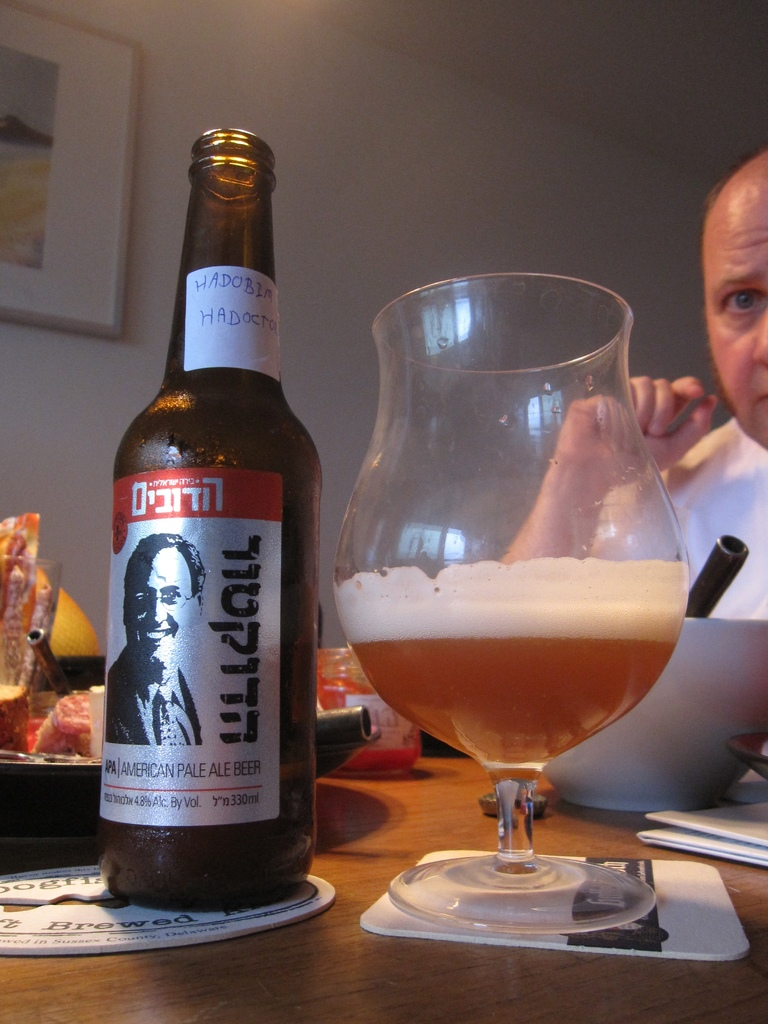Can you tell more about the label design on the beer bottle? The beer bottle features a unique label with a portrait, probably of a notable individual, which suggests a craft brewery's tribute or special edition. The typography and classic design elements give it a vintage appeal. What does this kind of label design say about the brewery’s brand? This label design indicates that the brewery values tradition and perhaps has a personal or historical connection to the figure on the label. It suggests craftsmanship and a personal touch, appealing to consumers who appreciate a story behind their beer. 